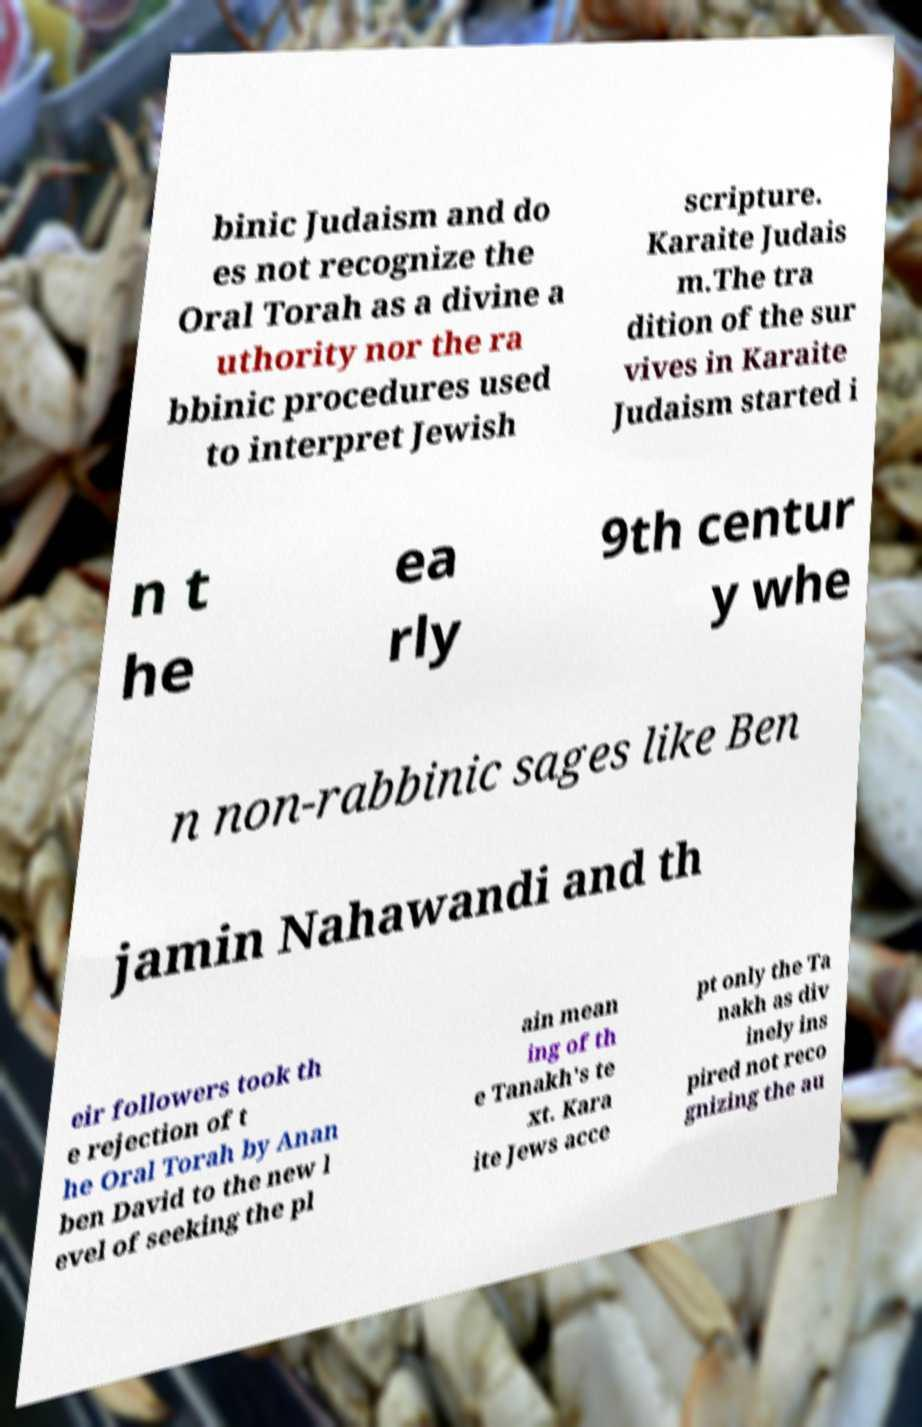Please read and relay the text visible in this image. What does it say? binic Judaism and do es not recognize the Oral Torah as a divine a uthority nor the ra bbinic procedures used to interpret Jewish scripture. Karaite Judais m.The tra dition of the sur vives in Karaite Judaism started i n t he ea rly 9th centur y whe n non-rabbinic sages like Ben jamin Nahawandi and th eir followers took th e rejection of t he Oral Torah by Anan ben David to the new l evel of seeking the pl ain mean ing of th e Tanakh's te xt. Kara ite Jews acce pt only the Ta nakh as div inely ins pired not reco gnizing the au 